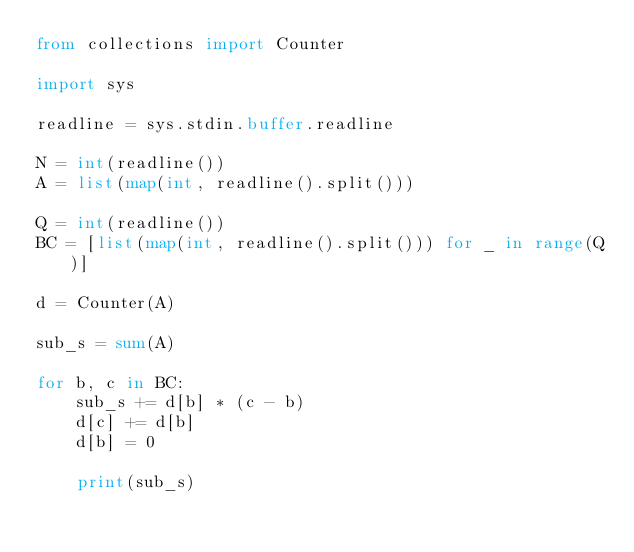<code> <loc_0><loc_0><loc_500><loc_500><_Python_>from collections import Counter

import sys

readline = sys.stdin.buffer.readline

N = int(readline())
A = list(map(int, readline().split()))

Q = int(readline())
BC = [list(map(int, readline().split())) for _ in range(Q)]

d = Counter(A)

sub_s = sum(A)

for b, c in BC:
    sub_s += d[b] * (c - b)
    d[c] += d[b]
    d[b] = 0

    print(sub_s)
</code> 